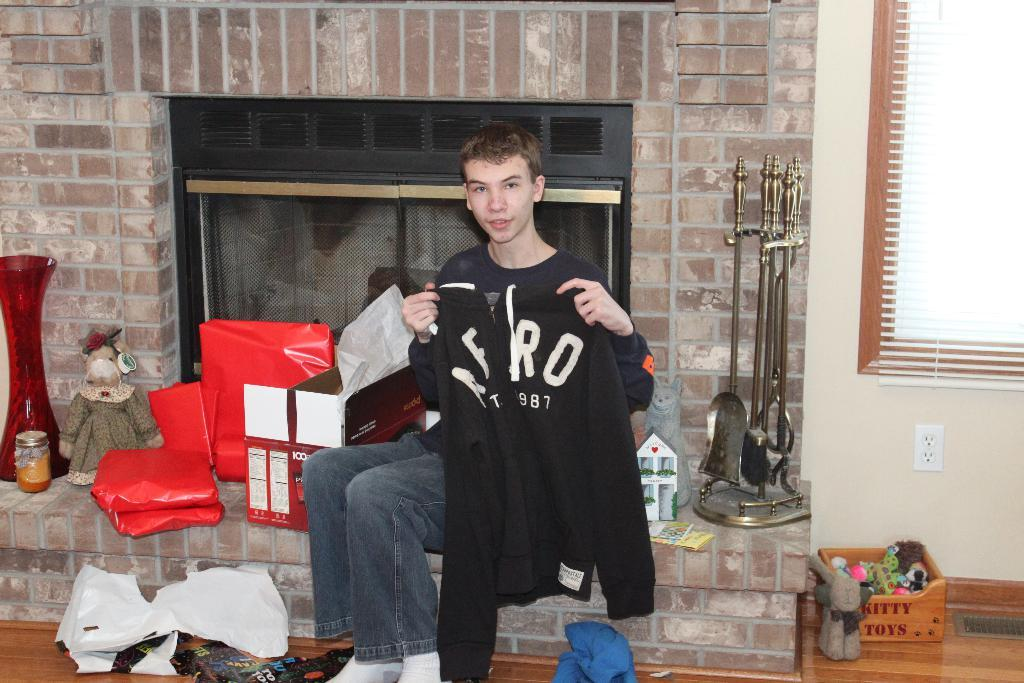<image>
Describe the image concisely. The shirt the boy is holding up says AFRO on it. 